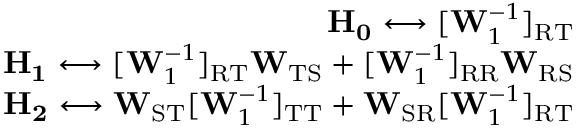<formula> <loc_0><loc_0><loc_500><loc_500>\begin{array} { r } { H _ { 0 } \longleftrightarrow [ W _ { 1 } ^ { - 1 } ] _ { R T } } \\ { H _ { 1 } \longleftrightarrow [ W _ { 1 } ^ { - 1 } ] _ { R T } W _ { T S } + [ W _ { 1 } ^ { - 1 } ] _ { R R } W _ { R S } } \\ { H _ { 2 } \longleftrightarrow W _ { S T } [ W _ { 1 } ^ { - 1 } ] _ { T T } + W _ { S R } [ W _ { 1 } ^ { - 1 } ] _ { R T } } \end{array}</formula> 